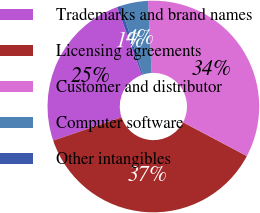Convert chart. <chart><loc_0><loc_0><loc_500><loc_500><pie_chart><fcel>Trademarks and brand names<fcel>Licensing agreements<fcel>Customer and distributor<fcel>Computer software<fcel>Other intangibles<nl><fcel>24.66%<fcel>37.03%<fcel>33.58%<fcel>4.19%<fcel>0.55%<nl></chart> 